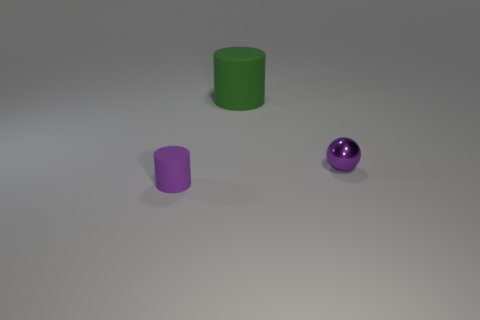Add 2 green metal spheres. How many objects exist? 5 Subtract all cylinders. How many objects are left? 1 Add 3 large cylinders. How many large cylinders are left? 4 Add 3 spheres. How many spheres exist? 4 Subtract 0 gray cylinders. How many objects are left? 3 Subtract all large things. Subtract all small balls. How many objects are left? 1 